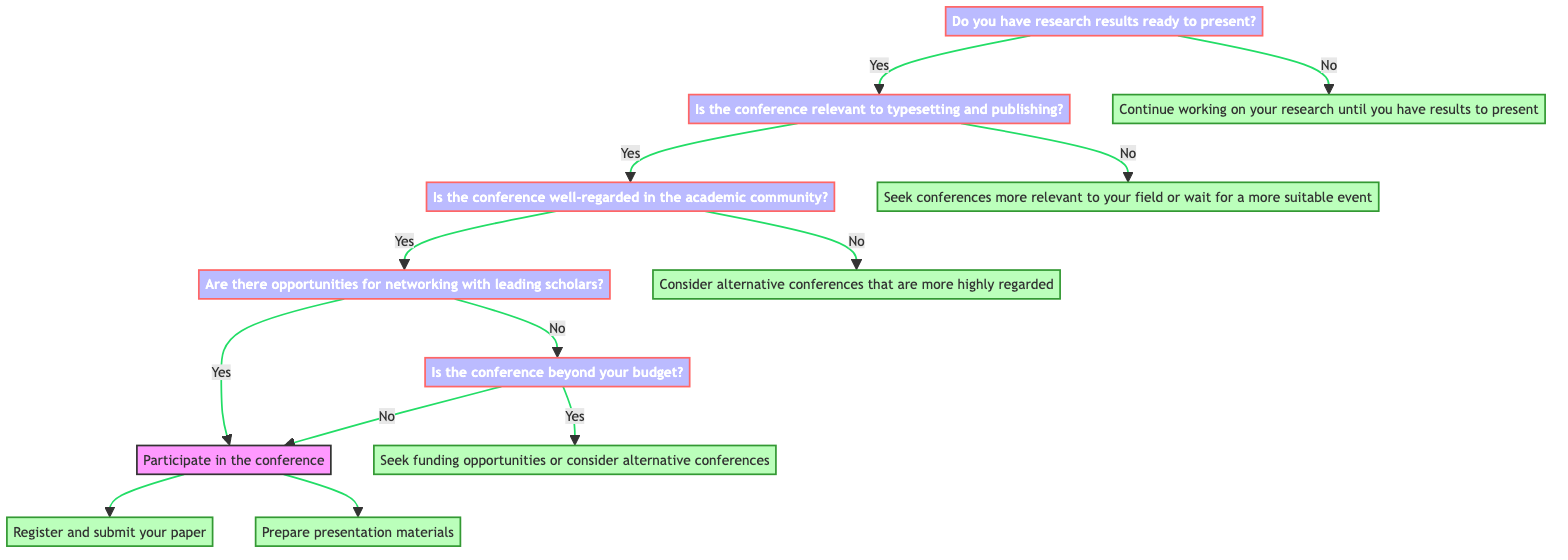What is the first question to answer in the diagram? The first question in the decision tree is "Do you have research results ready to present?" which is located at the start of the flowchart.
Answer: Do you have research results ready to present? How many decision points are in the diagram? There are five decision points in the diagram where yes/no questions are asked, leading to various outcomes.
Answer: Five What happens if the conference is not relevant to typesetting and publishing? If the conference is not relevant to typesetting and publishing, the pathway indicates that one should "Seek conferences more relevant to your field or wait for a more suitable event."
Answer: Seek conferences more relevant to your field or wait for a more suitable event What is the output if the conference is beyond your budget? If the conference is beyond your budget, the next step in the diagram suggests to "Seek funding opportunities or consider alternative conferences."
Answer: Seek funding opportunities or consider alternative conferences What are the potential actions if the conference is well-regarded and has networking opportunities? If the conference is well-regarded and has networking opportunities, the participant can take two actions: "Register and submit your paper" and "Prepare presentation materials."
Answer: Register and submit your paper, Prepare presentation materials What would happen if the researcher doesn’t have results ready to present? If the researcher does not have results ready to present, the decision tree directs them to "Continue working on your research until you have results to present."
Answer: Continue working on your research until you have results to present What is the next step if the conference is relevant but not well-regarded? If the conference is relevant but not well-regarded in the academic community, the decision tree advises "Consider alternative conferences that are more highly regarded."
Answer: Consider alternative conferences that are more highly regarded In total, how many actions can a participant take if they decide to participate in a well-regarded conference? A participant can take two actions if they decide to participate in a well-regarded conference. These are to register and submit a paper, and to prepare presentation materials.
Answer: Two actions 